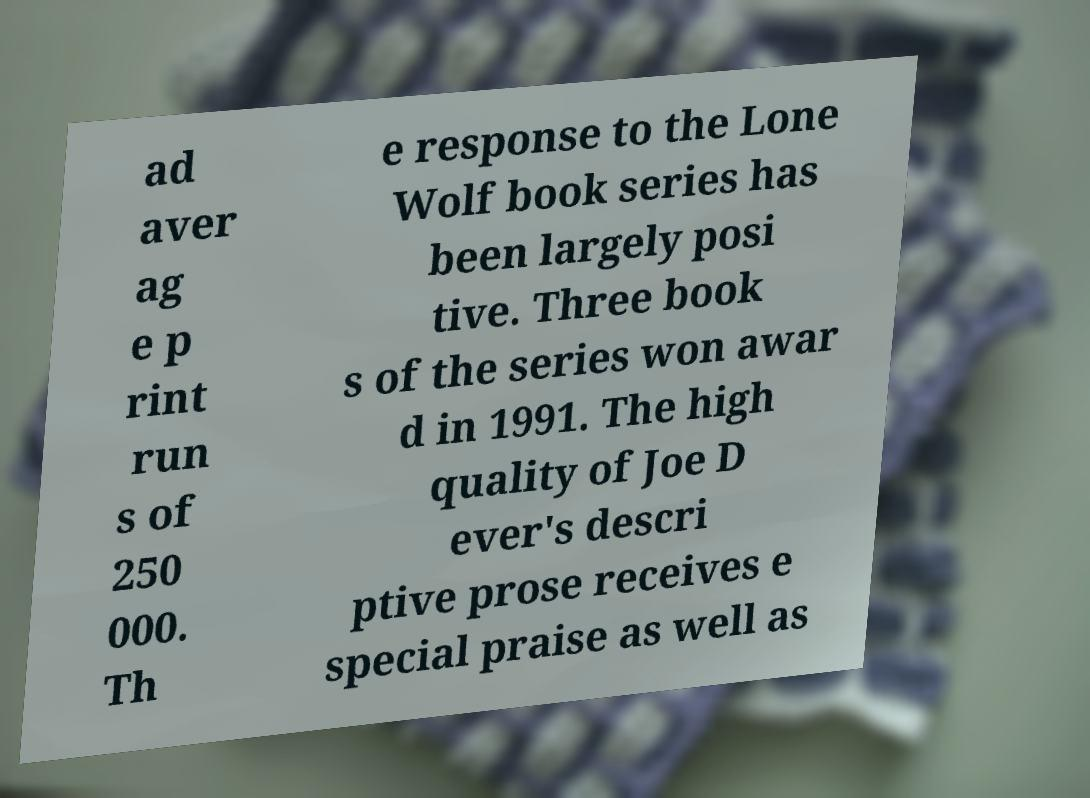I need the written content from this picture converted into text. Can you do that? ad aver ag e p rint run s of 250 000. Th e response to the Lone Wolf book series has been largely posi tive. Three book s of the series won awar d in 1991. The high quality of Joe D ever's descri ptive prose receives e special praise as well as 